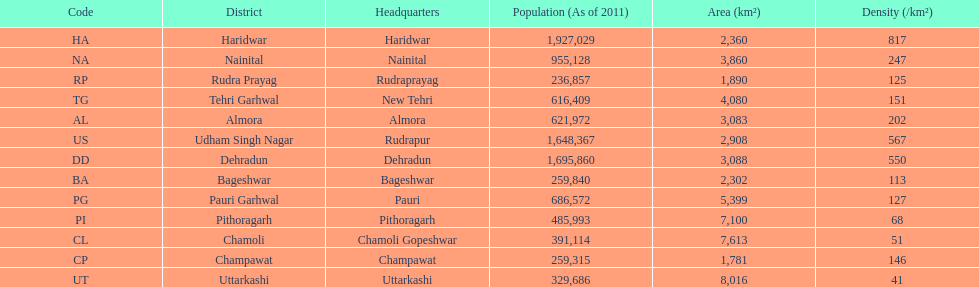What is the last code listed? UT. 